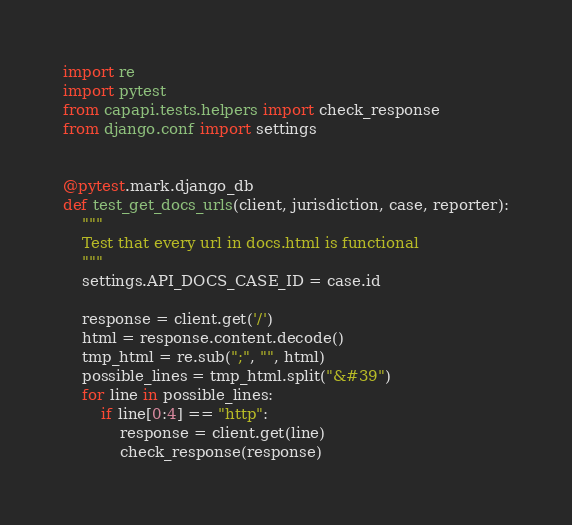Convert code to text. <code><loc_0><loc_0><loc_500><loc_500><_Python_>import re
import pytest
from capapi.tests.helpers import check_response
from django.conf import settings


@pytest.mark.django_db
def test_get_docs_urls(client, jurisdiction, case, reporter):
    """
    Test that every url in docs.html is functional
    """
    settings.API_DOCS_CASE_ID = case.id

    response = client.get('/')
    html = response.content.decode()
    tmp_html = re.sub(";", "", html)
    possible_lines = tmp_html.split("&#39")
    for line in possible_lines:
        if line[0:4] == "http":
            response = client.get(line)
            check_response(response)



</code> 